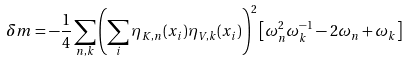Convert formula to latex. <formula><loc_0><loc_0><loc_500><loc_500>\delta m = - \frac { 1 } { 4 } \sum _ { n , k } \left ( \sum _ { i } \eta _ { K , n } ( x _ { i } ) \eta _ { V , k } ( x _ { i } ) \right ) ^ { 2 } \left [ \omega _ { n } ^ { 2 } \omega _ { k } ^ { - 1 } - 2 \omega _ { n } + \omega _ { k } \right ]</formula> 